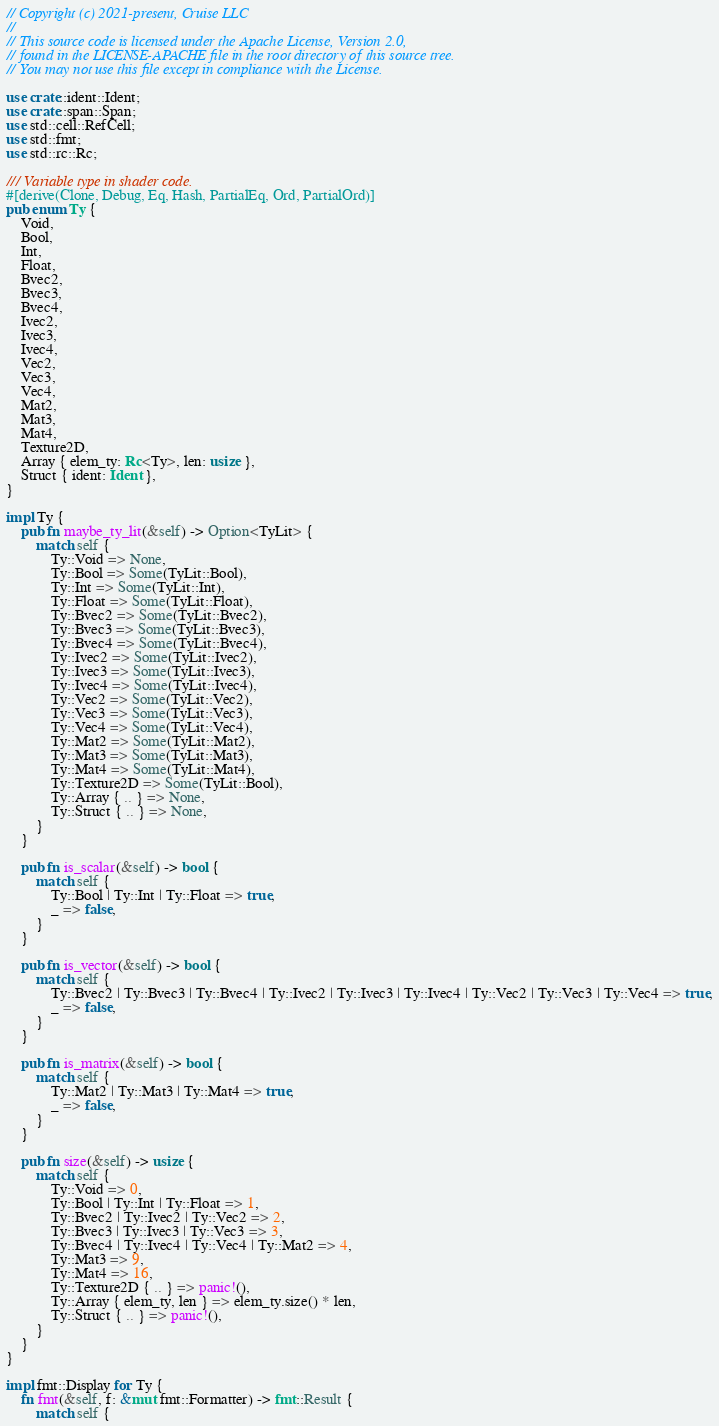Convert code to text. <code><loc_0><loc_0><loc_500><loc_500><_Rust_>// Copyright (c) 2021-present, Cruise LLC
//
// This source code is licensed under the Apache License, Version 2.0,
// found in the LICENSE-APACHE file in the root directory of this source tree.
// You may not use this file except in compliance with the License.

use crate::ident::Ident;
use crate::span::Span;
use std::cell::RefCell;
use std::fmt;
use std::rc::Rc;

/// Variable type in shader code.
#[derive(Clone, Debug, Eq, Hash, PartialEq, Ord, PartialOrd)]
pub enum Ty {
    Void,
    Bool,
    Int,
    Float,
    Bvec2,
    Bvec3,
    Bvec4,
    Ivec2,
    Ivec3,
    Ivec4,
    Vec2,
    Vec3,
    Vec4,
    Mat2,
    Mat3,
    Mat4,
    Texture2D,
    Array { elem_ty: Rc<Ty>, len: usize },
    Struct { ident: Ident },
}

impl Ty {
    pub fn maybe_ty_lit(&self) -> Option<TyLit> {
        match self {
            Ty::Void => None,
            Ty::Bool => Some(TyLit::Bool),
            Ty::Int => Some(TyLit::Int),
            Ty::Float => Some(TyLit::Float),
            Ty::Bvec2 => Some(TyLit::Bvec2),
            Ty::Bvec3 => Some(TyLit::Bvec3),
            Ty::Bvec4 => Some(TyLit::Bvec4),
            Ty::Ivec2 => Some(TyLit::Ivec2),
            Ty::Ivec3 => Some(TyLit::Ivec3),
            Ty::Ivec4 => Some(TyLit::Ivec4),
            Ty::Vec2 => Some(TyLit::Vec2),
            Ty::Vec3 => Some(TyLit::Vec3),
            Ty::Vec4 => Some(TyLit::Vec4),
            Ty::Mat2 => Some(TyLit::Mat2),
            Ty::Mat3 => Some(TyLit::Mat3),
            Ty::Mat4 => Some(TyLit::Mat4),
            Ty::Texture2D => Some(TyLit::Bool),
            Ty::Array { .. } => None,
            Ty::Struct { .. } => None,
        }
    }

    pub fn is_scalar(&self) -> bool {
        match self {
            Ty::Bool | Ty::Int | Ty::Float => true,
            _ => false,
        }
    }

    pub fn is_vector(&self) -> bool {
        match self {
            Ty::Bvec2 | Ty::Bvec3 | Ty::Bvec4 | Ty::Ivec2 | Ty::Ivec3 | Ty::Ivec4 | Ty::Vec2 | Ty::Vec3 | Ty::Vec4 => true,
            _ => false,
        }
    }

    pub fn is_matrix(&self) -> bool {
        match self {
            Ty::Mat2 | Ty::Mat3 | Ty::Mat4 => true,
            _ => false,
        }
    }

    pub fn size(&self) -> usize {
        match self {
            Ty::Void => 0,
            Ty::Bool | Ty::Int | Ty::Float => 1,
            Ty::Bvec2 | Ty::Ivec2 | Ty::Vec2 => 2,
            Ty::Bvec3 | Ty::Ivec3 | Ty::Vec3 => 3,
            Ty::Bvec4 | Ty::Ivec4 | Ty::Vec4 | Ty::Mat2 => 4,
            Ty::Mat3 => 9,
            Ty::Mat4 => 16,
            Ty::Texture2D { .. } => panic!(),
            Ty::Array { elem_ty, len } => elem_ty.size() * len,
            Ty::Struct { .. } => panic!(),
        }
    }
}

impl fmt::Display for Ty {
    fn fmt(&self, f: &mut fmt::Formatter) -> fmt::Result {
        match self {</code> 